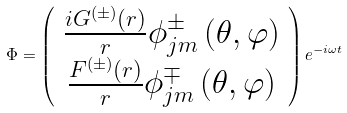Convert formula to latex. <formula><loc_0><loc_0><loc_500><loc_500>\Phi = \left ( \begin{array} { c } \frac { i G ^ { \left ( \pm \right ) } \left ( r \right ) } { r } \phi _ { j m } ^ { \pm } \left ( \theta , \varphi \right ) \\ \frac { F ^ { \left ( \pm \right ) } \left ( r \right ) } { r } \phi _ { j m } ^ { \mp } \left ( \theta , \varphi \right ) \end{array} \right ) e ^ { - i \omega t }</formula> 